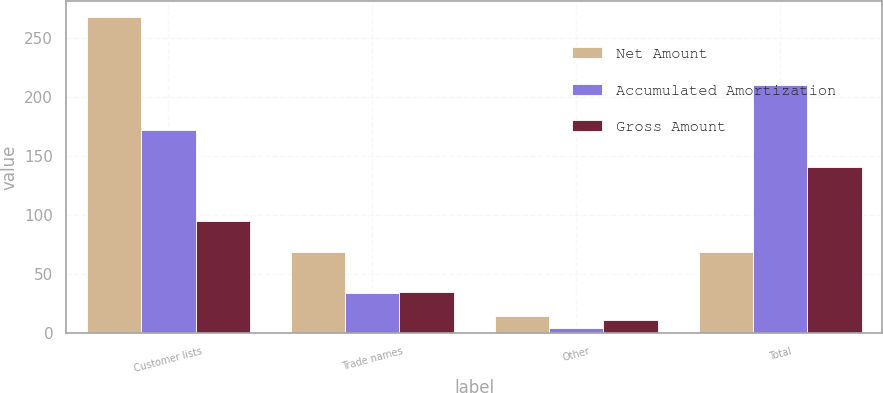Convert chart. <chart><loc_0><loc_0><loc_500><loc_500><stacked_bar_chart><ecel><fcel>Customer lists<fcel>Trade names<fcel>Other<fcel>Total<nl><fcel>Net Amount<fcel>267.3<fcel>68.8<fcel>14.4<fcel>68.8<nl><fcel>Accumulated Amortization<fcel>172.2<fcel>33.8<fcel>3.8<fcel>209.8<nl><fcel>Gross Amount<fcel>95.1<fcel>35<fcel>10.6<fcel>140.7<nl></chart> 